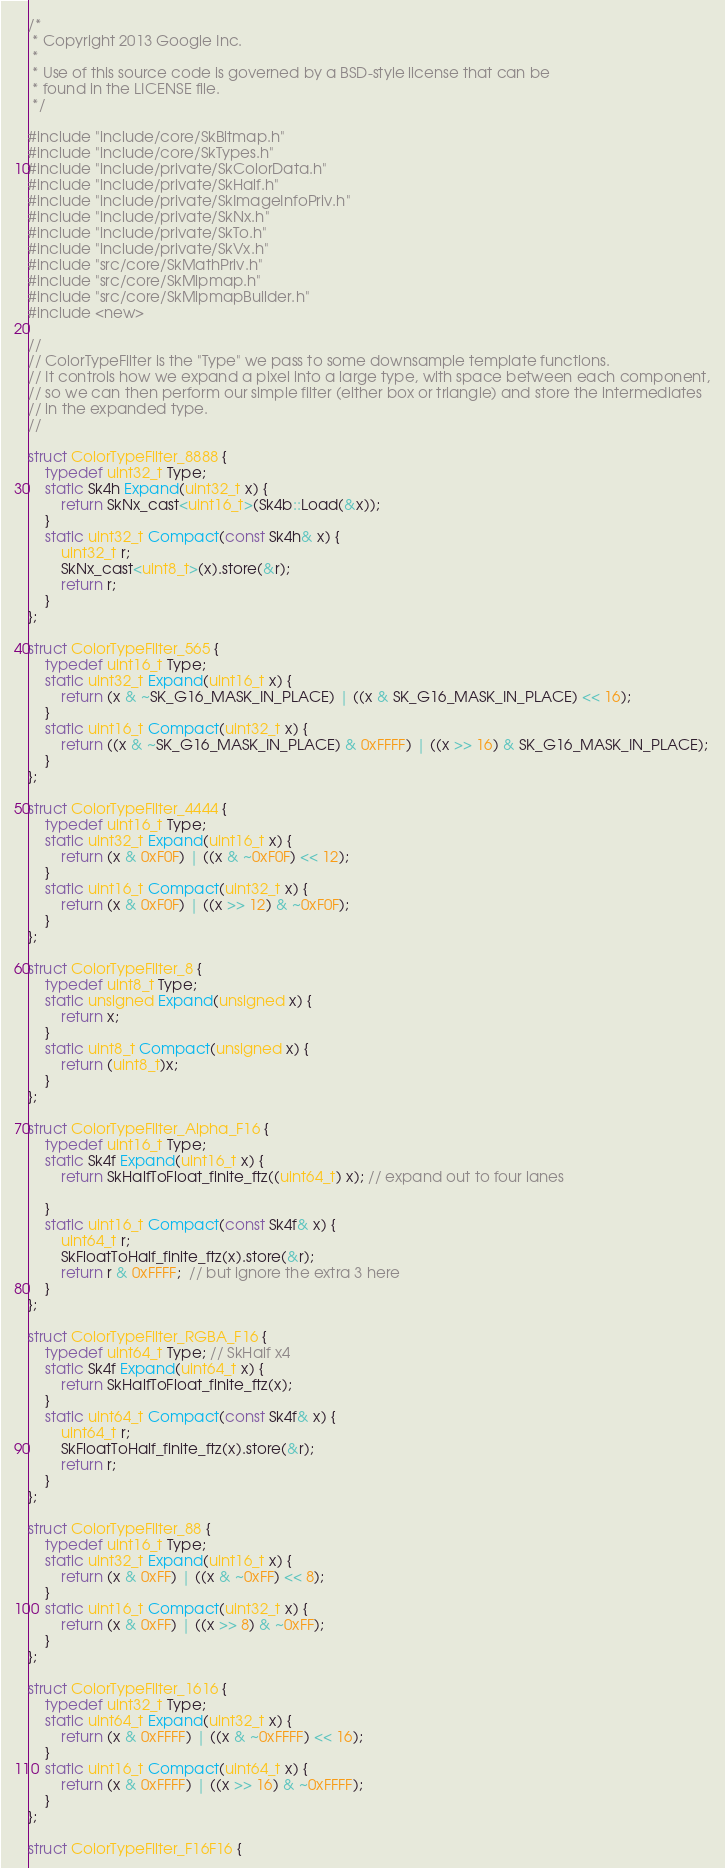<code> <loc_0><loc_0><loc_500><loc_500><_C++_>/*
 * Copyright 2013 Google Inc.
 *
 * Use of this source code is governed by a BSD-style license that can be
 * found in the LICENSE file.
 */

#include "include/core/SkBitmap.h"
#include "include/core/SkTypes.h"
#include "include/private/SkColorData.h"
#include "include/private/SkHalf.h"
#include "include/private/SkImageInfoPriv.h"
#include "include/private/SkNx.h"
#include "include/private/SkTo.h"
#include "include/private/SkVx.h"
#include "src/core/SkMathPriv.h"
#include "src/core/SkMipmap.h"
#include "src/core/SkMipmapBuilder.h"
#include <new>

//
// ColorTypeFilter is the "Type" we pass to some downsample template functions.
// It controls how we expand a pixel into a large type, with space between each component,
// so we can then perform our simple filter (either box or triangle) and store the intermediates
// in the expanded type.
//

struct ColorTypeFilter_8888 {
    typedef uint32_t Type;
    static Sk4h Expand(uint32_t x) {
        return SkNx_cast<uint16_t>(Sk4b::Load(&x));
    }
    static uint32_t Compact(const Sk4h& x) {
        uint32_t r;
        SkNx_cast<uint8_t>(x).store(&r);
        return r;
    }
};

struct ColorTypeFilter_565 {
    typedef uint16_t Type;
    static uint32_t Expand(uint16_t x) {
        return (x & ~SK_G16_MASK_IN_PLACE) | ((x & SK_G16_MASK_IN_PLACE) << 16);
    }
    static uint16_t Compact(uint32_t x) {
        return ((x & ~SK_G16_MASK_IN_PLACE) & 0xFFFF) | ((x >> 16) & SK_G16_MASK_IN_PLACE);
    }
};

struct ColorTypeFilter_4444 {
    typedef uint16_t Type;
    static uint32_t Expand(uint16_t x) {
        return (x & 0xF0F) | ((x & ~0xF0F) << 12);
    }
    static uint16_t Compact(uint32_t x) {
        return (x & 0xF0F) | ((x >> 12) & ~0xF0F);
    }
};

struct ColorTypeFilter_8 {
    typedef uint8_t Type;
    static unsigned Expand(unsigned x) {
        return x;
    }
    static uint8_t Compact(unsigned x) {
        return (uint8_t)x;
    }
};

struct ColorTypeFilter_Alpha_F16 {
    typedef uint16_t Type;
    static Sk4f Expand(uint16_t x) {
        return SkHalfToFloat_finite_ftz((uint64_t) x); // expand out to four lanes

    }
    static uint16_t Compact(const Sk4f& x) {
        uint64_t r;
        SkFloatToHalf_finite_ftz(x).store(&r);
        return r & 0xFFFF;  // but ignore the extra 3 here
    }
};

struct ColorTypeFilter_RGBA_F16 {
    typedef uint64_t Type; // SkHalf x4
    static Sk4f Expand(uint64_t x) {
        return SkHalfToFloat_finite_ftz(x);
    }
    static uint64_t Compact(const Sk4f& x) {
        uint64_t r;
        SkFloatToHalf_finite_ftz(x).store(&r);
        return r;
    }
};

struct ColorTypeFilter_88 {
    typedef uint16_t Type;
    static uint32_t Expand(uint16_t x) {
        return (x & 0xFF) | ((x & ~0xFF) << 8);
    }
    static uint16_t Compact(uint32_t x) {
        return (x & 0xFF) | ((x >> 8) & ~0xFF);
    }
};

struct ColorTypeFilter_1616 {
    typedef uint32_t Type;
    static uint64_t Expand(uint32_t x) {
        return (x & 0xFFFF) | ((x & ~0xFFFF) << 16);
    }
    static uint16_t Compact(uint64_t x) {
        return (x & 0xFFFF) | ((x >> 16) & ~0xFFFF);
    }
};

struct ColorTypeFilter_F16F16 {</code> 